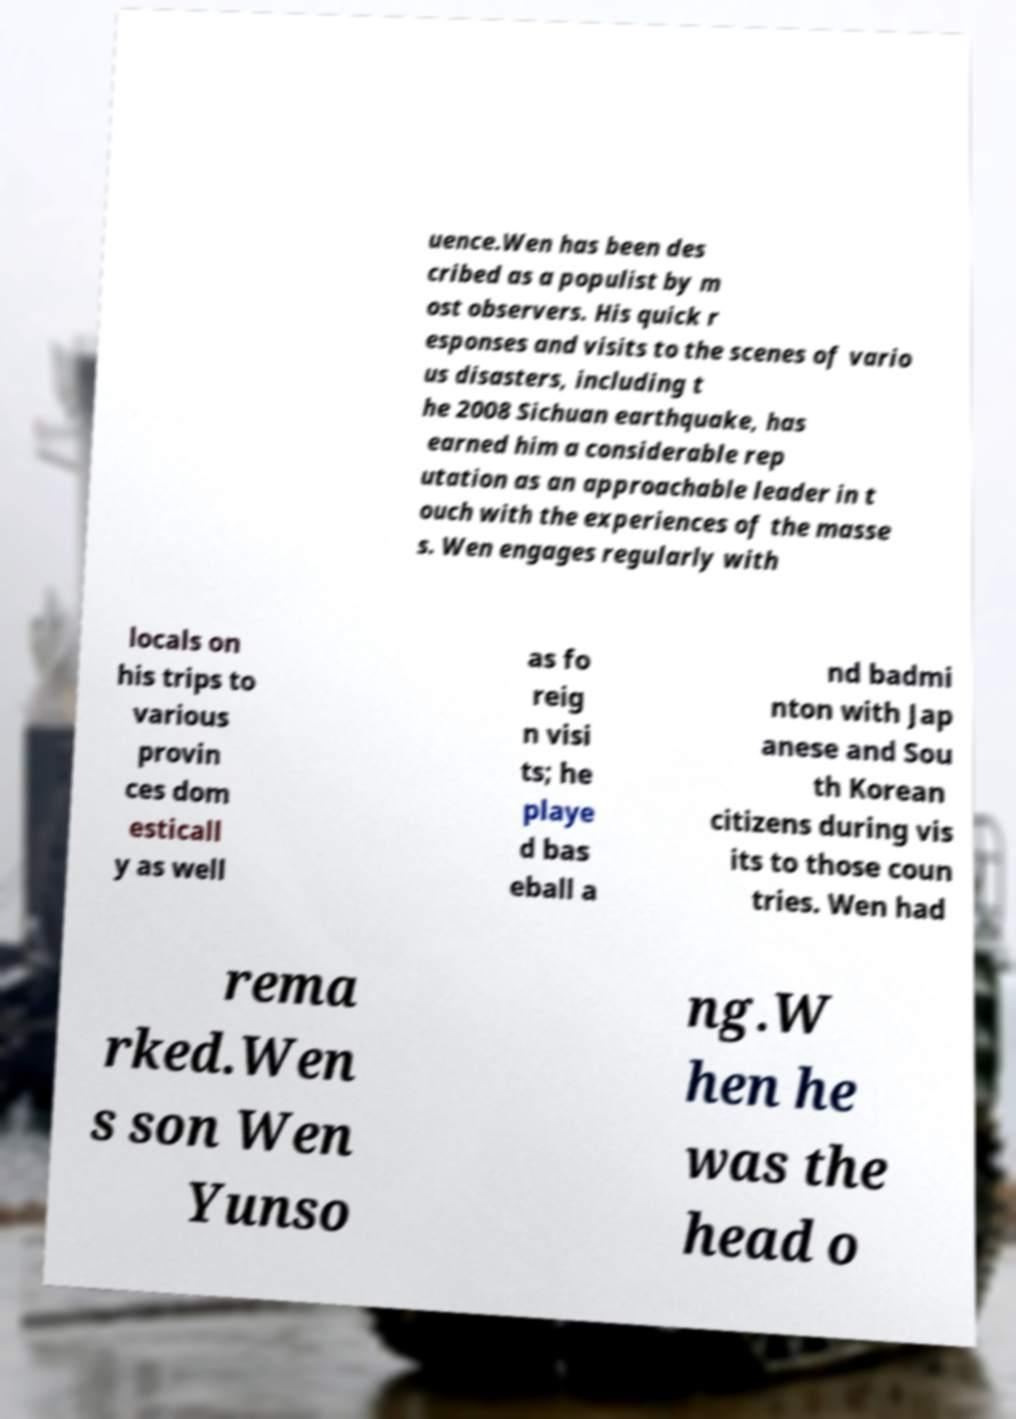Could you extract and type out the text from this image? uence.Wen has been des cribed as a populist by m ost observers. His quick r esponses and visits to the scenes of vario us disasters, including t he 2008 Sichuan earthquake, has earned him a considerable rep utation as an approachable leader in t ouch with the experiences of the masse s. Wen engages regularly with locals on his trips to various provin ces dom esticall y as well as fo reig n visi ts; he playe d bas eball a nd badmi nton with Jap anese and Sou th Korean citizens during vis its to those coun tries. Wen had rema rked.Wen s son Wen Yunso ng.W hen he was the head o 